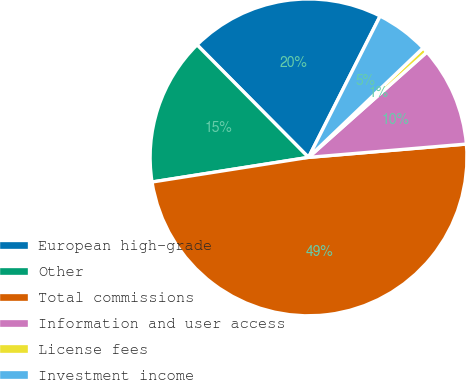Convert chart to OTSL. <chart><loc_0><loc_0><loc_500><loc_500><pie_chart><fcel>European high-grade<fcel>Other<fcel>Total commissions<fcel>Information and user access<fcel>License fees<fcel>Investment income<nl><fcel>19.89%<fcel>15.06%<fcel>48.86%<fcel>10.23%<fcel>0.57%<fcel>5.4%<nl></chart> 